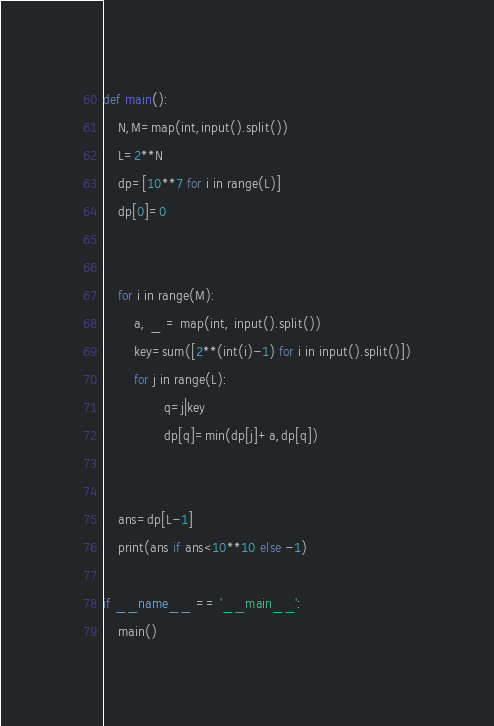Convert code to text. <code><loc_0><loc_0><loc_500><loc_500><_Python_>def main():
    N,M=map(int,input().split())
    L=2**N
    dp=[10**7 for i in range(L)]
    dp[0]=0


    for i in range(M):
        a, _ = map(int, input().split())
        key=sum([2**(int(i)-1) for i in input().split()])
        for j in range(L):
                q=j|key
                dp[q]=min(dp[j]+a,dp[q])


    ans=dp[L-1]
    print(ans if ans<10**10 else -1)

if __name__ == '__main__':
    main()</code> 